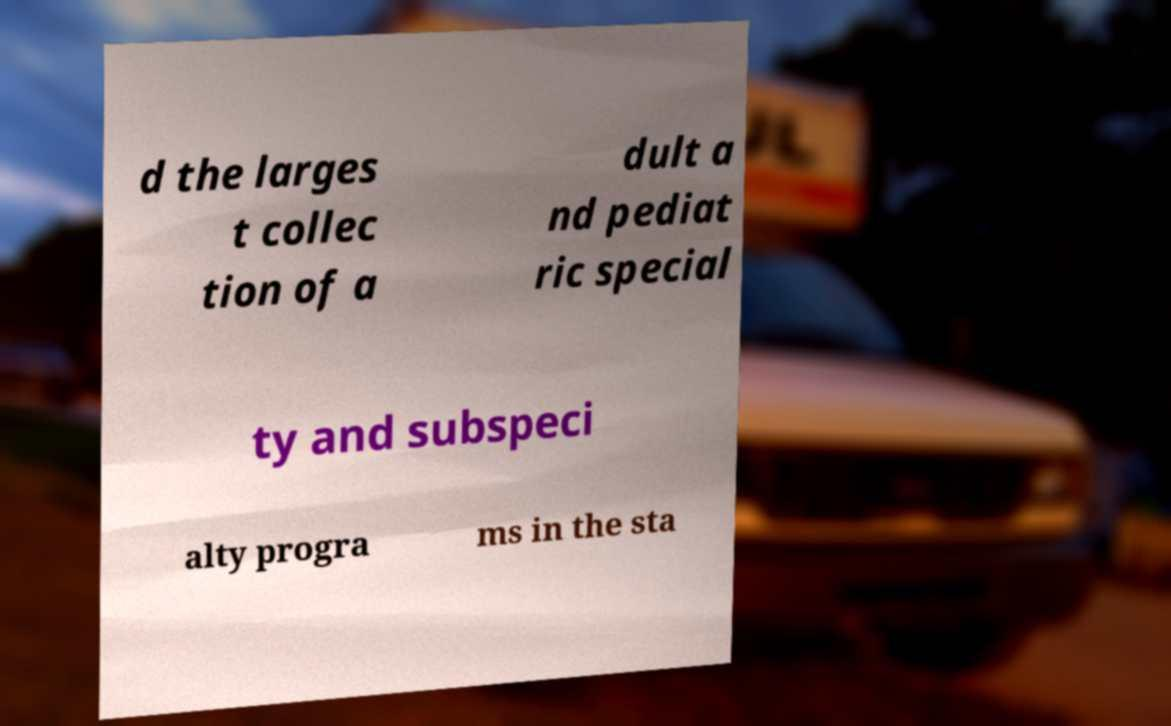Could you extract and type out the text from this image? d the larges t collec tion of a dult a nd pediat ric special ty and subspeci alty progra ms in the sta 